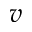<formula> <loc_0><loc_0><loc_500><loc_500>v</formula> 